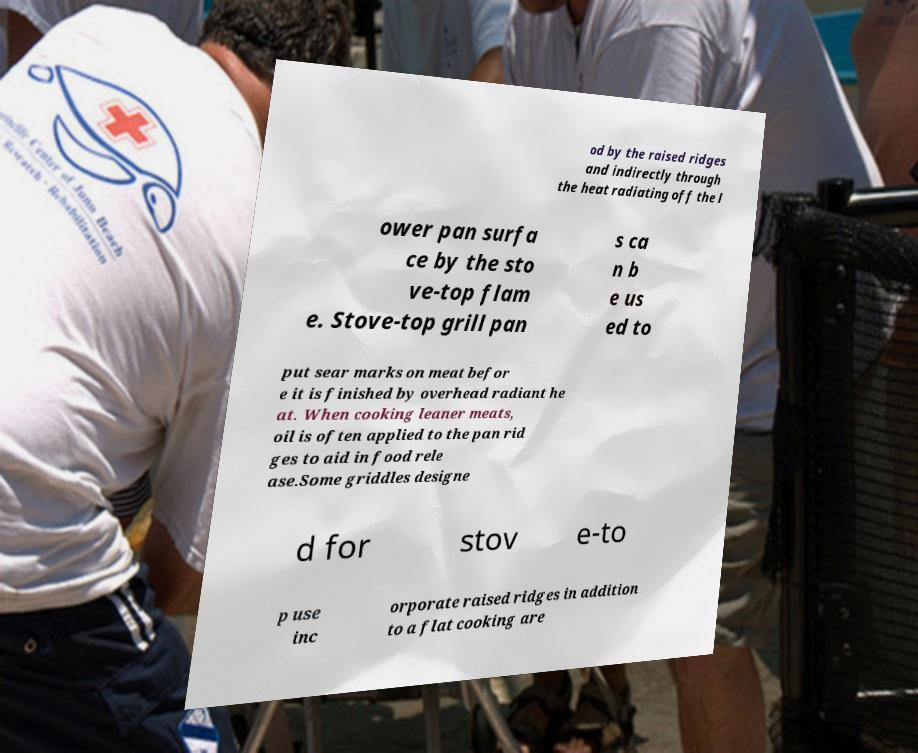Can you read and provide the text displayed in the image?This photo seems to have some interesting text. Can you extract and type it out for me? od by the raised ridges and indirectly through the heat radiating off the l ower pan surfa ce by the sto ve-top flam e. Stove-top grill pan s ca n b e us ed to put sear marks on meat befor e it is finished by overhead radiant he at. When cooking leaner meats, oil is often applied to the pan rid ges to aid in food rele ase.Some griddles designe d for stov e-to p use inc orporate raised ridges in addition to a flat cooking are 